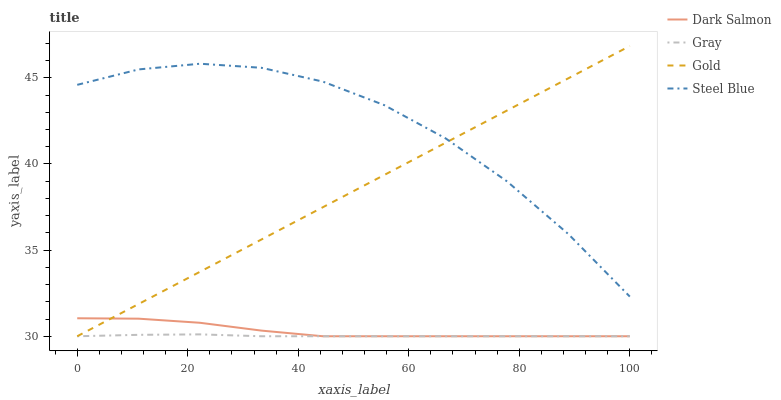Does Gray have the minimum area under the curve?
Answer yes or no. Yes. Does Steel Blue have the maximum area under the curve?
Answer yes or no. Yes. Does Dark Salmon have the minimum area under the curve?
Answer yes or no. No. Does Dark Salmon have the maximum area under the curve?
Answer yes or no. No. Is Gold the smoothest?
Answer yes or no. Yes. Is Steel Blue the roughest?
Answer yes or no. Yes. Is Dark Salmon the smoothest?
Answer yes or no. No. Is Dark Salmon the roughest?
Answer yes or no. No. Does Gray have the lowest value?
Answer yes or no. Yes. Does Steel Blue have the lowest value?
Answer yes or no. No. Does Gold have the highest value?
Answer yes or no. Yes. Does Dark Salmon have the highest value?
Answer yes or no. No. Is Gray less than Steel Blue?
Answer yes or no. Yes. Is Steel Blue greater than Gray?
Answer yes or no. Yes. Does Dark Salmon intersect Gold?
Answer yes or no. Yes. Is Dark Salmon less than Gold?
Answer yes or no. No. Is Dark Salmon greater than Gold?
Answer yes or no. No. Does Gray intersect Steel Blue?
Answer yes or no. No. 